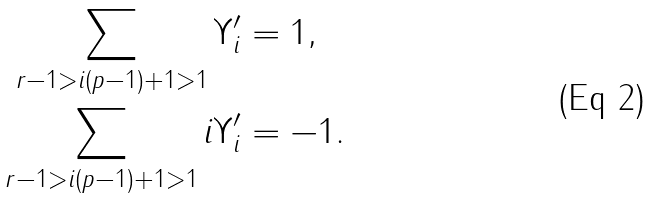<formula> <loc_0><loc_0><loc_500><loc_500>\sum _ { r - 1 > i ( p - 1 ) + 1 > 1 } \Upsilon _ { i } ^ { \prime } & = 1 , \\ \sum _ { r - 1 > i ( p - 1 ) + 1 > 1 } i \Upsilon _ { i } ^ { \prime } & = - 1 .</formula> 